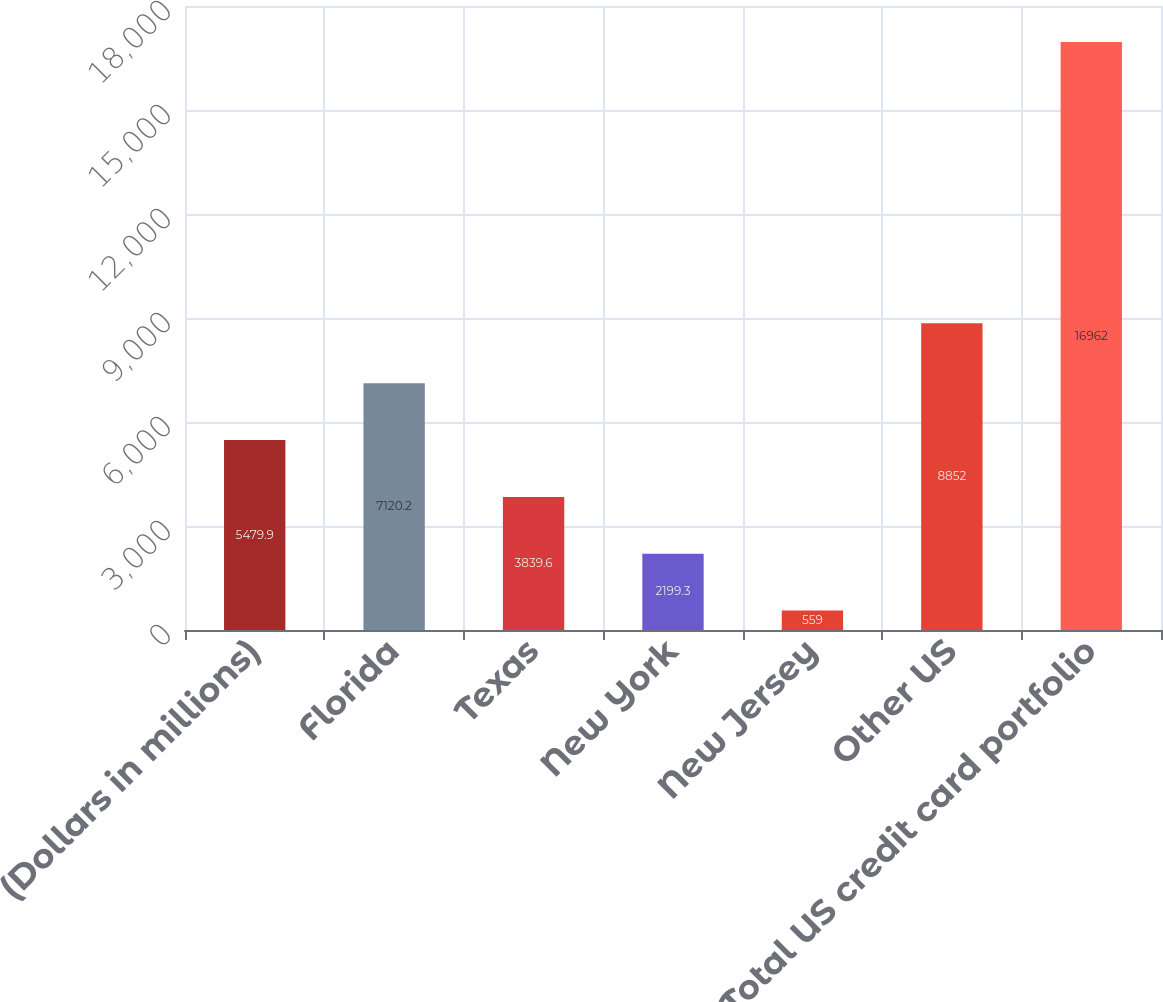Convert chart to OTSL. <chart><loc_0><loc_0><loc_500><loc_500><bar_chart><fcel>(Dollars in millions)<fcel>Florida<fcel>Texas<fcel>New York<fcel>New Jersey<fcel>Other US<fcel>Total US credit card portfolio<nl><fcel>5479.9<fcel>7120.2<fcel>3839.6<fcel>2199.3<fcel>559<fcel>8852<fcel>16962<nl></chart> 